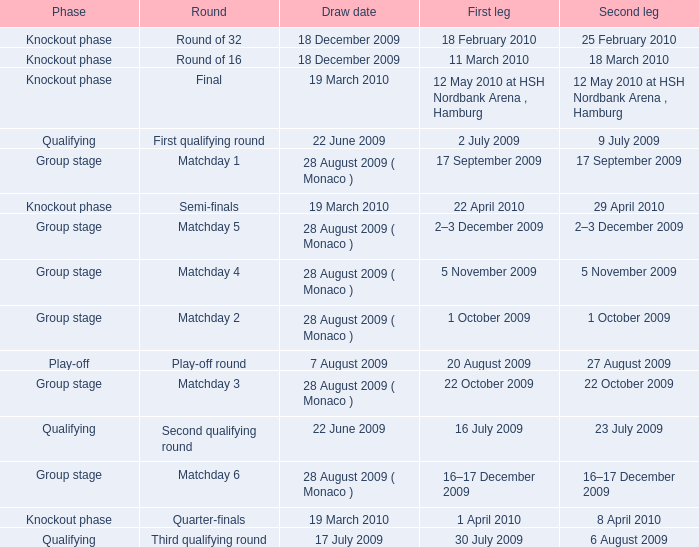Which phase is for the Matchday 4 Round? Group stage. 